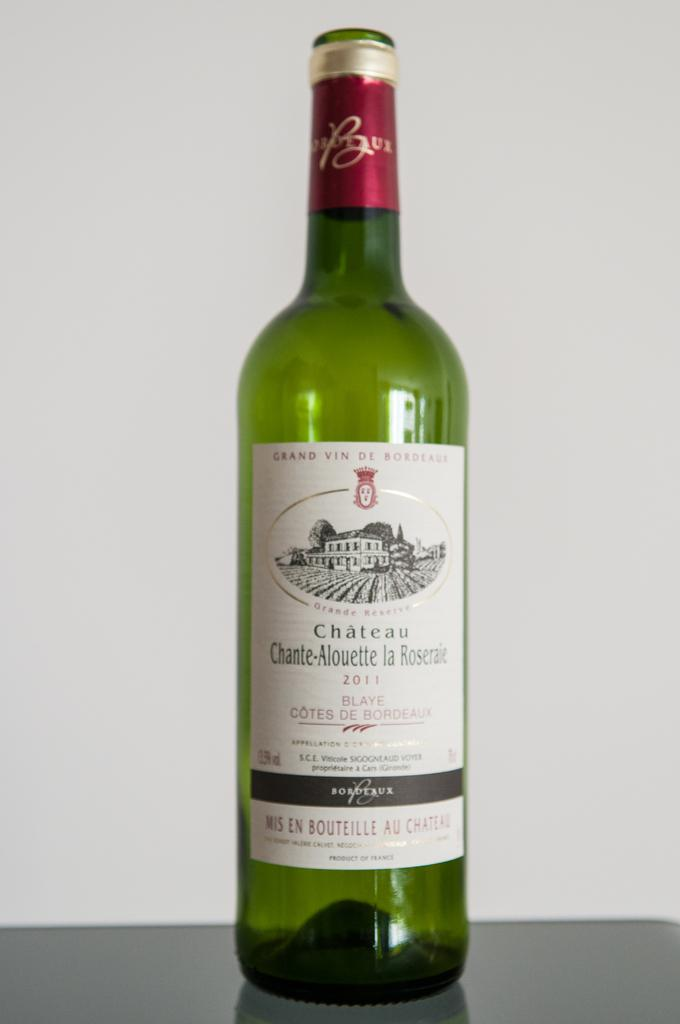<image>
Offer a succinct explanation of the picture presented. Bottle of alcohol with a label which says "2011" on it. 